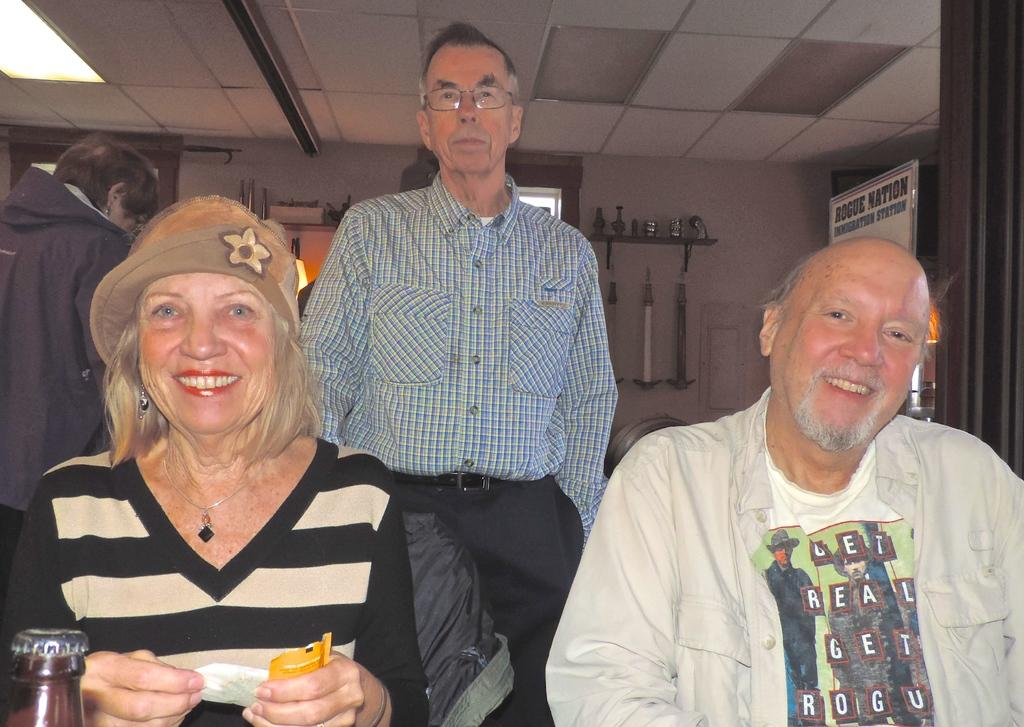<image>
Offer a succinct explanation of the picture presented. three older people, one wearing shirt that has get real get rogu on it and a rogue nation sign on wall 